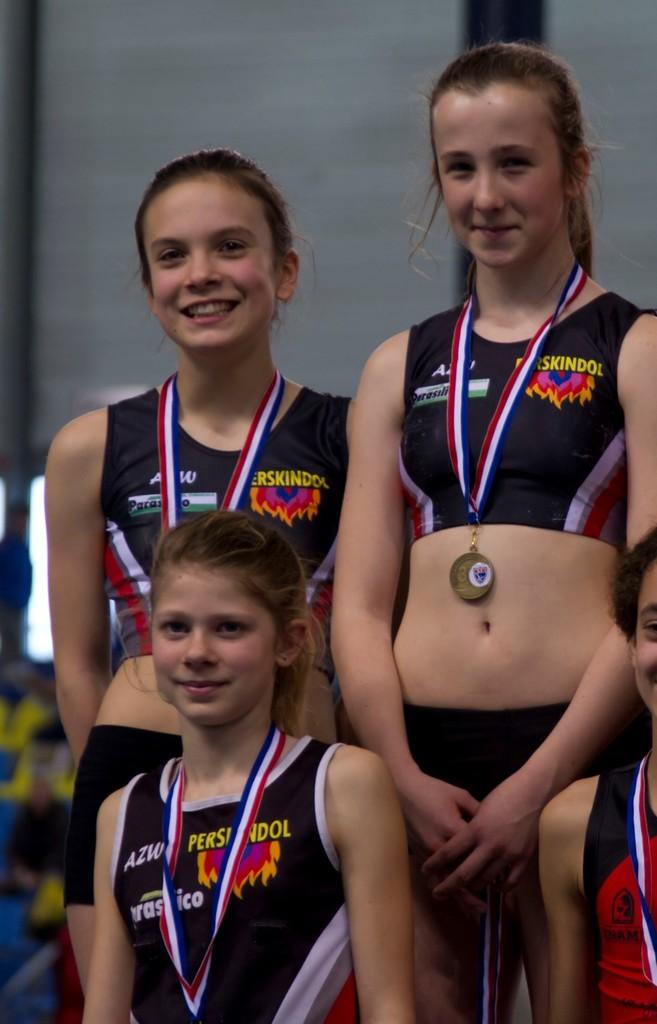Who or what can be seen in the image? There are people in the image. What are the people wearing in the image? The people are wearing medals. What type of pleasure can be smelled in the image? There is no mention of pleasure or smell in the image; it only features people wearing medals. 